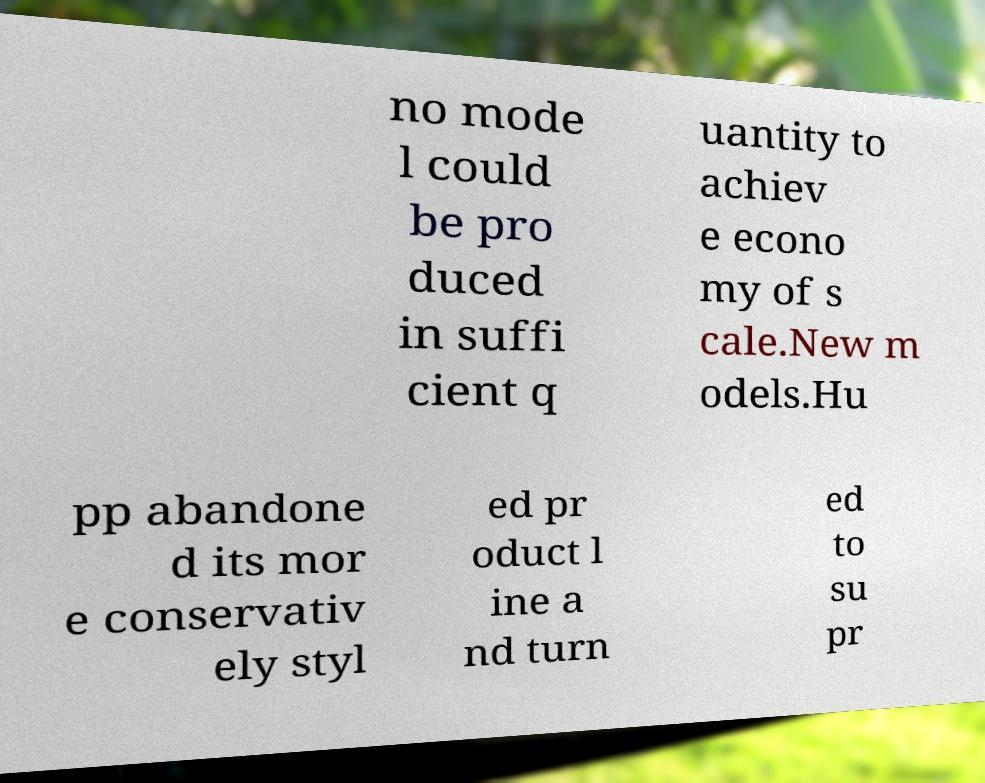Please read and relay the text visible in this image. What does it say? no mode l could be pro duced in suffi cient q uantity to achiev e econo my of s cale.New m odels.Hu pp abandone d its mor e conservativ ely styl ed pr oduct l ine a nd turn ed to su pr 